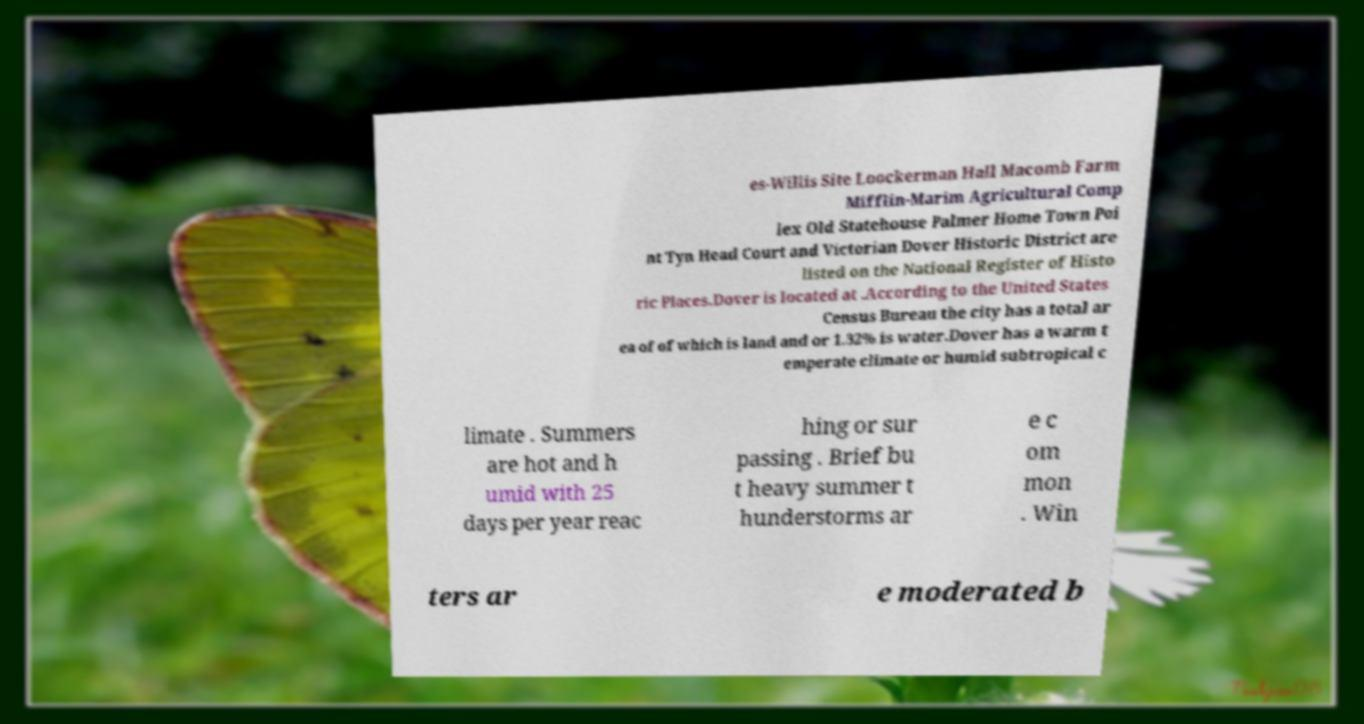Can you read and provide the text displayed in the image?This photo seems to have some interesting text. Can you extract and type it out for me? es-Willis Site Loockerman Hall Macomb Farm Mifflin-Marim Agricultural Comp lex Old Statehouse Palmer Home Town Poi nt Tyn Head Court and Victorian Dover Historic District are listed on the National Register of Histo ric Places.Dover is located at .According to the United States Census Bureau the city has a total ar ea of of which is land and or 1.32% is water.Dover has a warm t emperate climate or humid subtropical c limate . Summers are hot and h umid with 25 days per year reac hing or sur passing . Brief bu t heavy summer t hunderstorms ar e c om mon . Win ters ar e moderated b 